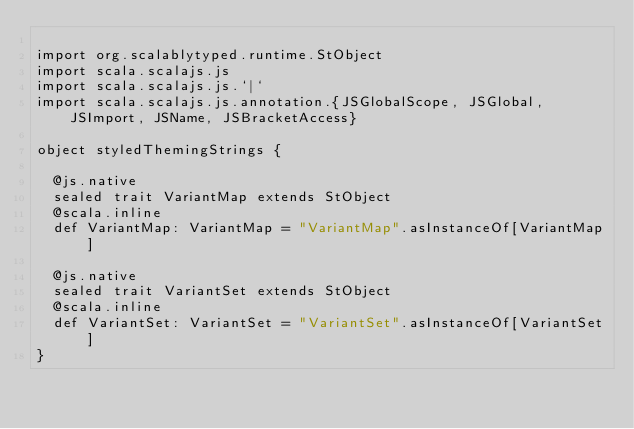Convert code to text. <code><loc_0><loc_0><loc_500><loc_500><_Scala_>
import org.scalablytyped.runtime.StObject
import scala.scalajs.js
import scala.scalajs.js.`|`
import scala.scalajs.js.annotation.{JSGlobalScope, JSGlobal, JSImport, JSName, JSBracketAccess}

object styledThemingStrings {
  
  @js.native
  sealed trait VariantMap extends StObject
  @scala.inline
  def VariantMap: VariantMap = "VariantMap".asInstanceOf[VariantMap]
  
  @js.native
  sealed trait VariantSet extends StObject
  @scala.inline
  def VariantSet: VariantSet = "VariantSet".asInstanceOf[VariantSet]
}
</code> 